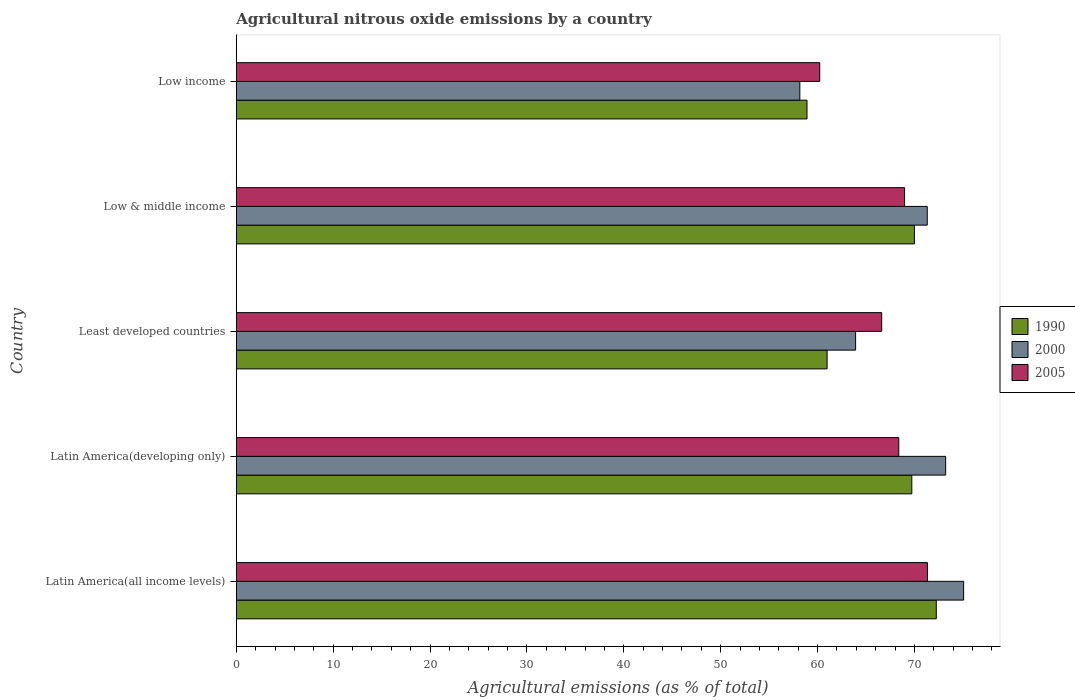Are the number of bars per tick equal to the number of legend labels?
Offer a very short reply. Yes. In how many cases, is the number of bars for a given country not equal to the number of legend labels?
Provide a succinct answer. 0. What is the amount of agricultural nitrous oxide emitted in 1990 in Latin America(developing only)?
Your answer should be compact. 69.73. Across all countries, what is the maximum amount of agricultural nitrous oxide emitted in 2000?
Provide a succinct answer. 75.08. Across all countries, what is the minimum amount of agricultural nitrous oxide emitted in 1990?
Your response must be concise. 58.91. In which country was the amount of agricultural nitrous oxide emitted in 2000 maximum?
Keep it short and to the point. Latin America(all income levels). In which country was the amount of agricultural nitrous oxide emitted in 2000 minimum?
Keep it short and to the point. Low income. What is the total amount of agricultural nitrous oxide emitted in 1990 in the graph?
Offer a very short reply. 331.88. What is the difference between the amount of agricultural nitrous oxide emitted in 2005 in Low & middle income and that in Low income?
Make the answer very short. 8.76. What is the difference between the amount of agricultural nitrous oxide emitted in 2005 in Latin America(developing only) and the amount of agricultural nitrous oxide emitted in 1990 in Least developed countries?
Keep it short and to the point. 7.4. What is the average amount of agricultural nitrous oxide emitted in 2000 per country?
Your answer should be very brief. 68.34. What is the difference between the amount of agricultural nitrous oxide emitted in 2005 and amount of agricultural nitrous oxide emitted in 2000 in Low income?
Offer a very short reply. 2.05. What is the ratio of the amount of agricultural nitrous oxide emitted in 1990 in Latin America(all income levels) to that in Latin America(developing only)?
Offer a terse response. 1.04. Is the amount of agricultural nitrous oxide emitted in 1990 in Latin America(all income levels) less than that in Least developed countries?
Provide a short and direct response. No. Is the difference between the amount of agricultural nitrous oxide emitted in 2005 in Latin America(all income levels) and Latin America(developing only) greater than the difference between the amount of agricultural nitrous oxide emitted in 2000 in Latin America(all income levels) and Latin America(developing only)?
Provide a succinct answer. Yes. What is the difference between the highest and the second highest amount of agricultural nitrous oxide emitted in 2005?
Give a very brief answer. 2.36. What is the difference between the highest and the lowest amount of agricultural nitrous oxide emitted in 2000?
Keep it short and to the point. 16.91. In how many countries, is the amount of agricultural nitrous oxide emitted in 2000 greater than the average amount of agricultural nitrous oxide emitted in 2000 taken over all countries?
Ensure brevity in your answer.  3. What does the 3rd bar from the top in Low & middle income represents?
Keep it short and to the point. 1990. What does the 2nd bar from the bottom in Latin America(all income levels) represents?
Provide a short and direct response. 2000. How many bars are there?
Keep it short and to the point. 15. Are all the bars in the graph horizontal?
Your answer should be compact. Yes. How many countries are there in the graph?
Your response must be concise. 5. What is the difference between two consecutive major ticks on the X-axis?
Keep it short and to the point. 10. Does the graph contain grids?
Offer a very short reply. No. How are the legend labels stacked?
Provide a succinct answer. Vertical. What is the title of the graph?
Provide a succinct answer. Agricultural nitrous oxide emissions by a country. What is the label or title of the X-axis?
Make the answer very short. Agricultural emissions (as % of total). What is the Agricultural emissions (as % of total) of 1990 in Latin America(all income levels)?
Provide a succinct answer. 72.26. What is the Agricultural emissions (as % of total) in 2000 in Latin America(all income levels)?
Provide a succinct answer. 75.08. What is the Agricultural emissions (as % of total) in 2005 in Latin America(all income levels)?
Your response must be concise. 71.34. What is the Agricultural emissions (as % of total) in 1990 in Latin America(developing only)?
Your answer should be compact. 69.73. What is the Agricultural emissions (as % of total) of 2000 in Latin America(developing only)?
Offer a terse response. 73.22. What is the Agricultural emissions (as % of total) of 2005 in Latin America(developing only)?
Your response must be concise. 68.38. What is the Agricultural emissions (as % of total) in 1990 in Least developed countries?
Offer a terse response. 60.99. What is the Agricultural emissions (as % of total) in 2000 in Least developed countries?
Your answer should be very brief. 63.93. What is the Agricultural emissions (as % of total) of 2005 in Least developed countries?
Keep it short and to the point. 66.62. What is the Agricultural emissions (as % of total) of 1990 in Low & middle income?
Ensure brevity in your answer.  70. What is the Agricultural emissions (as % of total) in 2000 in Low & middle income?
Your answer should be compact. 71.32. What is the Agricultural emissions (as % of total) of 2005 in Low & middle income?
Provide a short and direct response. 68.98. What is the Agricultural emissions (as % of total) in 1990 in Low income?
Your answer should be compact. 58.91. What is the Agricultural emissions (as % of total) of 2000 in Low income?
Offer a very short reply. 58.17. What is the Agricultural emissions (as % of total) in 2005 in Low income?
Your answer should be compact. 60.22. Across all countries, what is the maximum Agricultural emissions (as % of total) of 1990?
Your answer should be compact. 72.26. Across all countries, what is the maximum Agricultural emissions (as % of total) in 2000?
Your answer should be compact. 75.08. Across all countries, what is the maximum Agricultural emissions (as % of total) in 2005?
Ensure brevity in your answer.  71.34. Across all countries, what is the minimum Agricultural emissions (as % of total) in 1990?
Make the answer very short. 58.91. Across all countries, what is the minimum Agricultural emissions (as % of total) in 2000?
Your response must be concise. 58.17. Across all countries, what is the minimum Agricultural emissions (as % of total) in 2005?
Your response must be concise. 60.22. What is the total Agricultural emissions (as % of total) in 1990 in the graph?
Keep it short and to the point. 331.88. What is the total Agricultural emissions (as % of total) of 2000 in the graph?
Make the answer very short. 341.72. What is the total Agricultural emissions (as % of total) in 2005 in the graph?
Make the answer very short. 335.55. What is the difference between the Agricultural emissions (as % of total) of 1990 in Latin America(all income levels) and that in Latin America(developing only)?
Your answer should be compact. 2.53. What is the difference between the Agricultural emissions (as % of total) of 2000 in Latin America(all income levels) and that in Latin America(developing only)?
Your answer should be compact. 1.86. What is the difference between the Agricultural emissions (as % of total) in 2005 in Latin America(all income levels) and that in Latin America(developing only)?
Make the answer very short. 2.96. What is the difference between the Agricultural emissions (as % of total) of 1990 in Latin America(all income levels) and that in Least developed countries?
Your response must be concise. 11.27. What is the difference between the Agricultural emissions (as % of total) of 2000 in Latin America(all income levels) and that in Least developed countries?
Ensure brevity in your answer.  11.15. What is the difference between the Agricultural emissions (as % of total) of 2005 in Latin America(all income levels) and that in Least developed countries?
Offer a terse response. 4.72. What is the difference between the Agricultural emissions (as % of total) of 1990 in Latin America(all income levels) and that in Low & middle income?
Ensure brevity in your answer.  2.26. What is the difference between the Agricultural emissions (as % of total) of 2000 in Latin America(all income levels) and that in Low & middle income?
Provide a succinct answer. 3.75. What is the difference between the Agricultural emissions (as % of total) of 2005 in Latin America(all income levels) and that in Low & middle income?
Ensure brevity in your answer.  2.36. What is the difference between the Agricultural emissions (as % of total) of 1990 in Latin America(all income levels) and that in Low income?
Provide a succinct answer. 13.34. What is the difference between the Agricultural emissions (as % of total) of 2000 in Latin America(all income levels) and that in Low income?
Make the answer very short. 16.91. What is the difference between the Agricultural emissions (as % of total) of 2005 in Latin America(all income levels) and that in Low income?
Ensure brevity in your answer.  11.12. What is the difference between the Agricultural emissions (as % of total) in 1990 in Latin America(developing only) and that in Least developed countries?
Offer a terse response. 8.74. What is the difference between the Agricultural emissions (as % of total) in 2000 in Latin America(developing only) and that in Least developed countries?
Make the answer very short. 9.29. What is the difference between the Agricultural emissions (as % of total) in 2005 in Latin America(developing only) and that in Least developed countries?
Your answer should be very brief. 1.76. What is the difference between the Agricultural emissions (as % of total) of 1990 in Latin America(developing only) and that in Low & middle income?
Offer a terse response. -0.27. What is the difference between the Agricultural emissions (as % of total) of 2000 in Latin America(developing only) and that in Low & middle income?
Offer a terse response. 1.9. What is the difference between the Agricultural emissions (as % of total) of 2005 in Latin America(developing only) and that in Low & middle income?
Your answer should be compact. -0.6. What is the difference between the Agricultural emissions (as % of total) in 1990 in Latin America(developing only) and that in Low income?
Your response must be concise. 10.82. What is the difference between the Agricultural emissions (as % of total) in 2000 in Latin America(developing only) and that in Low income?
Offer a very short reply. 15.05. What is the difference between the Agricultural emissions (as % of total) of 2005 in Latin America(developing only) and that in Low income?
Keep it short and to the point. 8.16. What is the difference between the Agricultural emissions (as % of total) of 1990 in Least developed countries and that in Low & middle income?
Provide a succinct answer. -9.01. What is the difference between the Agricultural emissions (as % of total) of 2000 in Least developed countries and that in Low & middle income?
Give a very brief answer. -7.39. What is the difference between the Agricultural emissions (as % of total) in 2005 in Least developed countries and that in Low & middle income?
Your response must be concise. -2.36. What is the difference between the Agricultural emissions (as % of total) in 1990 in Least developed countries and that in Low income?
Make the answer very short. 2.07. What is the difference between the Agricultural emissions (as % of total) of 2000 in Least developed countries and that in Low income?
Ensure brevity in your answer.  5.76. What is the difference between the Agricultural emissions (as % of total) in 2005 in Least developed countries and that in Low income?
Your response must be concise. 6.4. What is the difference between the Agricultural emissions (as % of total) of 1990 in Low & middle income and that in Low income?
Ensure brevity in your answer.  11.09. What is the difference between the Agricultural emissions (as % of total) of 2000 in Low & middle income and that in Low income?
Keep it short and to the point. 13.15. What is the difference between the Agricultural emissions (as % of total) of 2005 in Low & middle income and that in Low income?
Keep it short and to the point. 8.76. What is the difference between the Agricultural emissions (as % of total) of 1990 in Latin America(all income levels) and the Agricultural emissions (as % of total) of 2000 in Latin America(developing only)?
Give a very brief answer. -0.97. What is the difference between the Agricultural emissions (as % of total) of 1990 in Latin America(all income levels) and the Agricultural emissions (as % of total) of 2005 in Latin America(developing only)?
Offer a very short reply. 3.87. What is the difference between the Agricultural emissions (as % of total) of 2000 in Latin America(all income levels) and the Agricultural emissions (as % of total) of 2005 in Latin America(developing only)?
Your answer should be compact. 6.69. What is the difference between the Agricultural emissions (as % of total) in 1990 in Latin America(all income levels) and the Agricultural emissions (as % of total) in 2000 in Least developed countries?
Provide a short and direct response. 8.33. What is the difference between the Agricultural emissions (as % of total) of 1990 in Latin America(all income levels) and the Agricultural emissions (as % of total) of 2005 in Least developed countries?
Provide a succinct answer. 5.64. What is the difference between the Agricultural emissions (as % of total) in 2000 in Latin America(all income levels) and the Agricultural emissions (as % of total) in 2005 in Least developed countries?
Your answer should be compact. 8.46. What is the difference between the Agricultural emissions (as % of total) of 1990 in Latin America(all income levels) and the Agricultural emissions (as % of total) of 2000 in Low & middle income?
Offer a terse response. 0.93. What is the difference between the Agricultural emissions (as % of total) of 1990 in Latin America(all income levels) and the Agricultural emissions (as % of total) of 2005 in Low & middle income?
Provide a succinct answer. 3.27. What is the difference between the Agricultural emissions (as % of total) of 2000 in Latin America(all income levels) and the Agricultural emissions (as % of total) of 2005 in Low & middle income?
Your response must be concise. 6.1. What is the difference between the Agricultural emissions (as % of total) in 1990 in Latin America(all income levels) and the Agricultural emissions (as % of total) in 2000 in Low income?
Ensure brevity in your answer.  14.08. What is the difference between the Agricultural emissions (as % of total) of 1990 in Latin America(all income levels) and the Agricultural emissions (as % of total) of 2005 in Low income?
Offer a very short reply. 12.03. What is the difference between the Agricultural emissions (as % of total) in 2000 in Latin America(all income levels) and the Agricultural emissions (as % of total) in 2005 in Low income?
Offer a very short reply. 14.85. What is the difference between the Agricultural emissions (as % of total) in 1990 in Latin America(developing only) and the Agricultural emissions (as % of total) in 2000 in Least developed countries?
Offer a terse response. 5.8. What is the difference between the Agricultural emissions (as % of total) in 1990 in Latin America(developing only) and the Agricultural emissions (as % of total) in 2005 in Least developed countries?
Your answer should be compact. 3.11. What is the difference between the Agricultural emissions (as % of total) in 2000 in Latin America(developing only) and the Agricultural emissions (as % of total) in 2005 in Least developed countries?
Offer a terse response. 6.6. What is the difference between the Agricultural emissions (as % of total) of 1990 in Latin America(developing only) and the Agricultural emissions (as % of total) of 2000 in Low & middle income?
Your answer should be very brief. -1.59. What is the difference between the Agricultural emissions (as % of total) of 1990 in Latin America(developing only) and the Agricultural emissions (as % of total) of 2005 in Low & middle income?
Give a very brief answer. 0.75. What is the difference between the Agricultural emissions (as % of total) of 2000 in Latin America(developing only) and the Agricultural emissions (as % of total) of 2005 in Low & middle income?
Your response must be concise. 4.24. What is the difference between the Agricultural emissions (as % of total) in 1990 in Latin America(developing only) and the Agricultural emissions (as % of total) in 2000 in Low income?
Offer a terse response. 11.56. What is the difference between the Agricultural emissions (as % of total) in 1990 in Latin America(developing only) and the Agricultural emissions (as % of total) in 2005 in Low income?
Provide a succinct answer. 9.51. What is the difference between the Agricultural emissions (as % of total) of 2000 in Latin America(developing only) and the Agricultural emissions (as % of total) of 2005 in Low income?
Provide a short and direct response. 13. What is the difference between the Agricultural emissions (as % of total) in 1990 in Least developed countries and the Agricultural emissions (as % of total) in 2000 in Low & middle income?
Your response must be concise. -10.34. What is the difference between the Agricultural emissions (as % of total) of 1990 in Least developed countries and the Agricultural emissions (as % of total) of 2005 in Low & middle income?
Offer a very short reply. -8. What is the difference between the Agricultural emissions (as % of total) of 2000 in Least developed countries and the Agricultural emissions (as % of total) of 2005 in Low & middle income?
Ensure brevity in your answer.  -5.05. What is the difference between the Agricultural emissions (as % of total) in 1990 in Least developed countries and the Agricultural emissions (as % of total) in 2000 in Low income?
Provide a succinct answer. 2.81. What is the difference between the Agricultural emissions (as % of total) of 1990 in Least developed countries and the Agricultural emissions (as % of total) of 2005 in Low income?
Your answer should be very brief. 0.76. What is the difference between the Agricultural emissions (as % of total) of 2000 in Least developed countries and the Agricultural emissions (as % of total) of 2005 in Low income?
Keep it short and to the point. 3.7. What is the difference between the Agricultural emissions (as % of total) of 1990 in Low & middle income and the Agricultural emissions (as % of total) of 2000 in Low income?
Your response must be concise. 11.83. What is the difference between the Agricultural emissions (as % of total) of 1990 in Low & middle income and the Agricultural emissions (as % of total) of 2005 in Low income?
Provide a succinct answer. 9.77. What is the difference between the Agricultural emissions (as % of total) of 2000 in Low & middle income and the Agricultural emissions (as % of total) of 2005 in Low income?
Give a very brief answer. 11.1. What is the average Agricultural emissions (as % of total) in 1990 per country?
Ensure brevity in your answer.  66.38. What is the average Agricultural emissions (as % of total) of 2000 per country?
Provide a succinct answer. 68.34. What is the average Agricultural emissions (as % of total) in 2005 per country?
Ensure brevity in your answer.  67.11. What is the difference between the Agricultural emissions (as % of total) in 1990 and Agricultural emissions (as % of total) in 2000 in Latin America(all income levels)?
Provide a succinct answer. -2.82. What is the difference between the Agricultural emissions (as % of total) in 1990 and Agricultural emissions (as % of total) in 2005 in Latin America(all income levels)?
Make the answer very short. 0.91. What is the difference between the Agricultural emissions (as % of total) of 2000 and Agricultural emissions (as % of total) of 2005 in Latin America(all income levels)?
Provide a short and direct response. 3.74. What is the difference between the Agricultural emissions (as % of total) of 1990 and Agricultural emissions (as % of total) of 2000 in Latin America(developing only)?
Provide a short and direct response. -3.49. What is the difference between the Agricultural emissions (as % of total) of 1990 and Agricultural emissions (as % of total) of 2005 in Latin America(developing only)?
Provide a succinct answer. 1.35. What is the difference between the Agricultural emissions (as % of total) of 2000 and Agricultural emissions (as % of total) of 2005 in Latin America(developing only)?
Ensure brevity in your answer.  4.84. What is the difference between the Agricultural emissions (as % of total) of 1990 and Agricultural emissions (as % of total) of 2000 in Least developed countries?
Offer a terse response. -2.94. What is the difference between the Agricultural emissions (as % of total) of 1990 and Agricultural emissions (as % of total) of 2005 in Least developed countries?
Provide a short and direct response. -5.63. What is the difference between the Agricultural emissions (as % of total) in 2000 and Agricultural emissions (as % of total) in 2005 in Least developed countries?
Keep it short and to the point. -2.69. What is the difference between the Agricultural emissions (as % of total) of 1990 and Agricultural emissions (as % of total) of 2000 in Low & middle income?
Your answer should be very brief. -1.33. What is the difference between the Agricultural emissions (as % of total) in 1990 and Agricultural emissions (as % of total) in 2005 in Low & middle income?
Provide a succinct answer. 1.02. What is the difference between the Agricultural emissions (as % of total) in 2000 and Agricultural emissions (as % of total) in 2005 in Low & middle income?
Provide a short and direct response. 2.34. What is the difference between the Agricultural emissions (as % of total) in 1990 and Agricultural emissions (as % of total) in 2000 in Low income?
Offer a very short reply. 0.74. What is the difference between the Agricultural emissions (as % of total) of 1990 and Agricultural emissions (as % of total) of 2005 in Low income?
Ensure brevity in your answer.  -1.31. What is the difference between the Agricultural emissions (as % of total) in 2000 and Agricultural emissions (as % of total) in 2005 in Low income?
Offer a terse response. -2.05. What is the ratio of the Agricultural emissions (as % of total) in 1990 in Latin America(all income levels) to that in Latin America(developing only)?
Provide a short and direct response. 1.04. What is the ratio of the Agricultural emissions (as % of total) of 2000 in Latin America(all income levels) to that in Latin America(developing only)?
Keep it short and to the point. 1.03. What is the ratio of the Agricultural emissions (as % of total) of 2005 in Latin America(all income levels) to that in Latin America(developing only)?
Offer a very short reply. 1.04. What is the ratio of the Agricultural emissions (as % of total) of 1990 in Latin America(all income levels) to that in Least developed countries?
Your answer should be compact. 1.18. What is the ratio of the Agricultural emissions (as % of total) in 2000 in Latin America(all income levels) to that in Least developed countries?
Offer a very short reply. 1.17. What is the ratio of the Agricultural emissions (as % of total) in 2005 in Latin America(all income levels) to that in Least developed countries?
Provide a short and direct response. 1.07. What is the ratio of the Agricultural emissions (as % of total) in 1990 in Latin America(all income levels) to that in Low & middle income?
Your response must be concise. 1.03. What is the ratio of the Agricultural emissions (as % of total) of 2000 in Latin America(all income levels) to that in Low & middle income?
Your answer should be very brief. 1.05. What is the ratio of the Agricultural emissions (as % of total) of 2005 in Latin America(all income levels) to that in Low & middle income?
Make the answer very short. 1.03. What is the ratio of the Agricultural emissions (as % of total) of 1990 in Latin America(all income levels) to that in Low income?
Offer a very short reply. 1.23. What is the ratio of the Agricultural emissions (as % of total) in 2000 in Latin America(all income levels) to that in Low income?
Make the answer very short. 1.29. What is the ratio of the Agricultural emissions (as % of total) in 2005 in Latin America(all income levels) to that in Low income?
Your answer should be compact. 1.18. What is the ratio of the Agricultural emissions (as % of total) in 1990 in Latin America(developing only) to that in Least developed countries?
Keep it short and to the point. 1.14. What is the ratio of the Agricultural emissions (as % of total) of 2000 in Latin America(developing only) to that in Least developed countries?
Make the answer very short. 1.15. What is the ratio of the Agricultural emissions (as % of total) of 2005 in Latin America(developing only) to that in Least developed countries?
Ensure brevity in your answer.  1.03. What is the ratio of the Agricultural emissions (as % of total) of 2000 in Latin America(developing only) to that in Low & middle income?
Provide a succinct answer. 1.03. What is the ratio of the Agricultural emissions (as % of total) of 2005 in Latin America(developing only) to that in Low & middle income?
Provide a succinct answer. 0.99. What is the ratio of the Agricultural emissions (as % of total) of 1990 in Latin America(developing only) to that in Low income?
Make the answer very short. 1.18. What is the ratio of the Agricultural emissions (as % of total) in 2000 in Latin America(developing only) to that in Low income?
Your answer should be very brief. 1.26. What is the ratio of the Agricultural emissions (as % of total) of 2005 in Latin America(developing only) to that in Low income?
Offer a very short reply. 1.14. What is the ratio of the Agricultural emissions (as % of total) of 1990 in Least developed countries to that in Low & middle income?
Give a very brief answer. 0.87. What is the ratio of the Agricultural emissions (as % of total) in 2000 in Least developed countries to that in Low & middle income?
Provide a short and direct response. 0.9. What is the ratio of the Agricultural emissions (as % of total) of 2005 in Least developed countries to that in Low & middle income?
Your answer should be very brief. 0.97. What is the ratio of the Agricultural emissions (as % of total) of 1990 in Least developed countries to that in Low income?
Your answer should be very brief. 1.04. What is the ratio of the Agricultural emissions (as % of total) in 2000 in Least developed countries to that in Low income?
Offer a terse response. 1.1. What is the ratio of the Agricultural emissions (as % of total) of 2005 in Least developed countries to that in Low income?
Offer a very short reply. 1.11. What is the ratio of the Agricultural emissions (as % of total) in 1990 in Low & middle income to that in Low income?
Ensure brevity in your answer.  1.19. What is the ratio of the Agricultural emissions (as % of total) in 2000 in Low & middle income to that in Low income?
Ensure brevity in your answer.  1.23. What is the ratio of the Agricultural emissions (as % of total) of 2005 in Low & middle income to that in Low income?
Keep it short and to the point. 1.15. What is the difference between the highest and the second highest Agricultural emissions (as % of total) in 1990?
Keep it short and to the point. 2.26. What is the difference between the highest and the second highest Agricultural emissions (as % of total) in 2000?
Provide a short and direct response. 1.86. What is the difference between the highest and the second highest Agricultural emissions (as % of total) in 2005?
Offer a terse response. 2.36. What is the difference between the highest and the lowest Agricultural emissions (as % of total) of 1990?
Offer a very short reply. 13.34. What is the difference between the highest and the lowest Agricultural emissions (as % of total) of 2000?
Ensure brevity in your answer.  16.91. What is the difference between the highest and the lowest Agricultural emissions (as % of total) of 2005?
Make the answer very short. 11.12. 